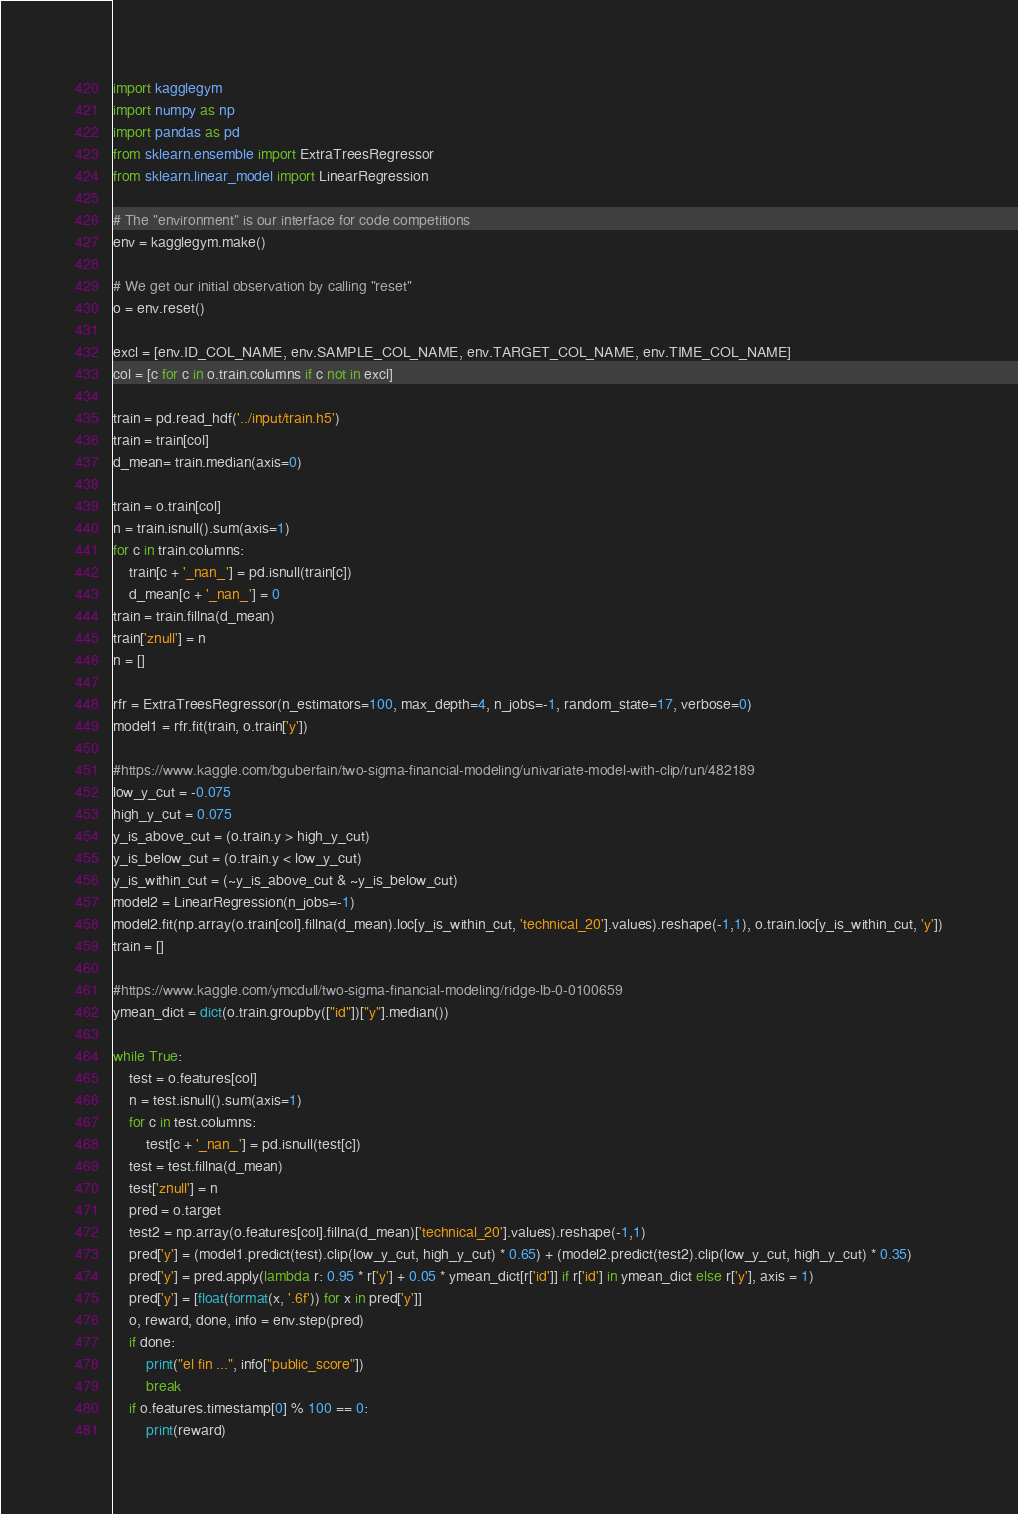Convert code to text. <code><loc_0><loc_0><loc_500><loc_500><_Python_>import kagglegym
import numpy as np
import pandas as pd
from sklearn.ensemble import ExtraTreesRegressor
from sklearn.linear_model import LinearRegression

# The "environment" is our interface for code competitions
env = kagglegym.make()

# We get our initial observation by calling "reset"
o = env.reset()

excl = [env.ID_COL_NAME, env.SAMPLE_COL_NAME, env.TARGET_COL_NAME, env.TIME_COL_NAME]
col = [c for c in o.train.columns if c not in excl]

train = pd.read_hdf('../input/train.h5')
train = train[col]
d_mean= train.median(axis=0)

train = o.train[col]
n = train.isnull().sum(axis=1)
for c in train.columns:
    train[c + '_nan_'] = pd.isnull(train[c])
    d_mean[c + '_nan_'] = 0
train = train.fillna(d_mean)
train['znull'] = n
n = []

rfr = ExtraTreesRegressor(n_estimators=100, max_depth=4, n_jobs=-1, random_state=17, verbose=0)
model1 = rfr.fit(train, o.train['y'])

#https://www.kaggle.com/bguberfain/two-sigma-financial-modeling/univariate-model-with-clip/run/482189
low_y_cut = -0.075
high_y_cut = 0.075
y_is_above_cut = (o.train.y > high_y_cut)
y_is_below_cut = (o.train.y < low_y_cut)
y_is_within_cut = (~y_is_above_cut & ~y_is_below_cut)
model2 = LinearRegression(n_jobs=-1)
model2.fit(np.array(o.train[col].fillna(d_mean).loc[y_is_within_cut, 'technical_20'].values).reshape(-1,1), o.train.loc[y_is_within_cut, 'y'])
train = []

#https://www.kaggle.com/ymcdull/two-sigma-financial-modeling/ridge-lb-0-0100659
ymean_dict = dict(o.train.groupby(["id"])["y"].median())

while True:
    test = o.features[col]
    n = test.isnull().sum(axis=1)
    for c in test.columns:
        test[c + '_nan_'] = pd.isnull(test[c])
    test = test.fillna(d_mean)
    test['znull'] = n
    pred = o.target
    test2 = np.array(o.features[col].fillna(d_mean)['technical_20'].values).reshape(-1,1)
    pred['y'] = (model1.predict(test).clip(low_y_cut, high_y_cut) * 0.65) + (model2.predict(test2).clip(low_y_cut, high_y_cut) * 0.35)
    pred['y'] = pred.apply(lambda r: 0.95 * r['y'] + 0.05 * ymean_dict[r['id']] if r['id'] in ymean_dict else r['y'], axis = 1)
    pred['y'] = [float(format(x, '.6f')) for x in pred['y']]
    o, reward, done, info = env.step(pred)
    if done:
        print("el fin ...", info["public_score"])
        break
    if o.features.timestamp[0] % 100 == 0:
        print(reward)
</code> 